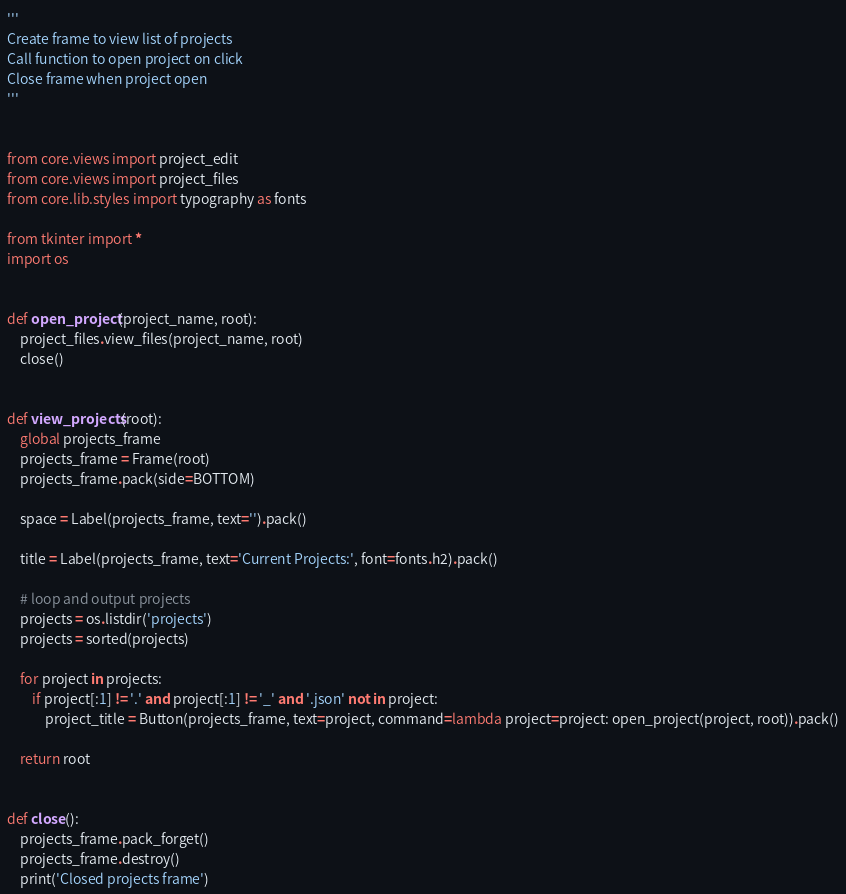Convert code to text. <code><loc_0><loc_0><loc_500><loc_500><_Python_>'''
Create frame to view list of projects
Call function to open project on click
Close frame when project open
'''


from core.views import project_edit
from core.views import project_files
from core.lib.styles import typography as fonts

from tkinter import *
import os


def open_project(project_name, root):
    project_files.view_files(project_name, root)
    close()


def view_projects(root):
    global projects_frame
    projects_frame = Frame(root)
    projects_frame.pack(side=BOTTOM)

    space = Label(projects_frame, text='').pack()

    title = Label(projects_frame, text='Current Projects:', font=fonts.h2).pack()
    
    # loop and output projects
    projects = os.listdir('projects')
    projects = sorted(projects)
    
    for project in projects:
        if project[:1] != '.' and project[:1] != '_' and '.json' not in project:
            project_title = Button(projects_frame, text=project, command=lambda project=project: open_project(project, root)).pack()
        
    return root


def close():
    projects_frame.pack_forget()
    projects_frame.destroy()
    print('Closed projects frame')
</code> 